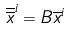<formula> <loc_0><loc_0><loc_500><loc_500>\overline { \overline { x } } ^ { i } = B \overline { x } ^ { i }</formula> 